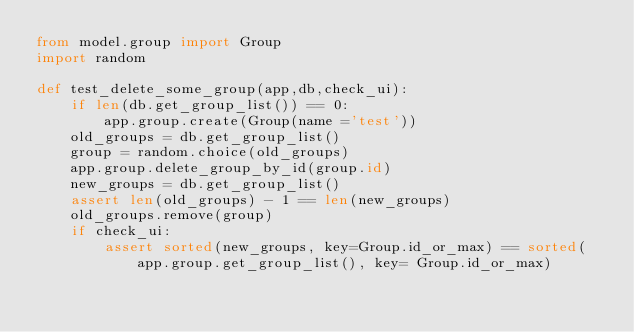Convert code to text. <code><loc_0><loc_0><loc_500><loc_500><_Python_>from model.group import Group
import random

def test_delete_some_group(app,db,check_ui):
    if len(db.get_group_list()) == 0:
        app.group.create(Group(name ='test'))
    old_groups = db.get_group_list()
    group = random.choice(old_groups)
    app.group.delete_group_by_id(group.id)
    new_groups = db.get_group_list()
    assert len(old_groups) - 1 == len(new_groups)
    old_groups.remove(group)
    if check_ui:
        assert sorted(new_groups, key=Group.id_or_max) == sorted(app.group.get_group_list(), key= Group.id_or_max)

</code> 